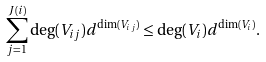<formula> <loc_0><loc_0><loc_500><loc_500>\sum _ { j = 1 } ^ { J ( i ) } \deg ( V _ { i j } ) d ^ { \dim ( V _ { i j } ) } \leq \deg ( V _ { i } ) d ^ { \dim ( V _ { i } ) } .</formula> 